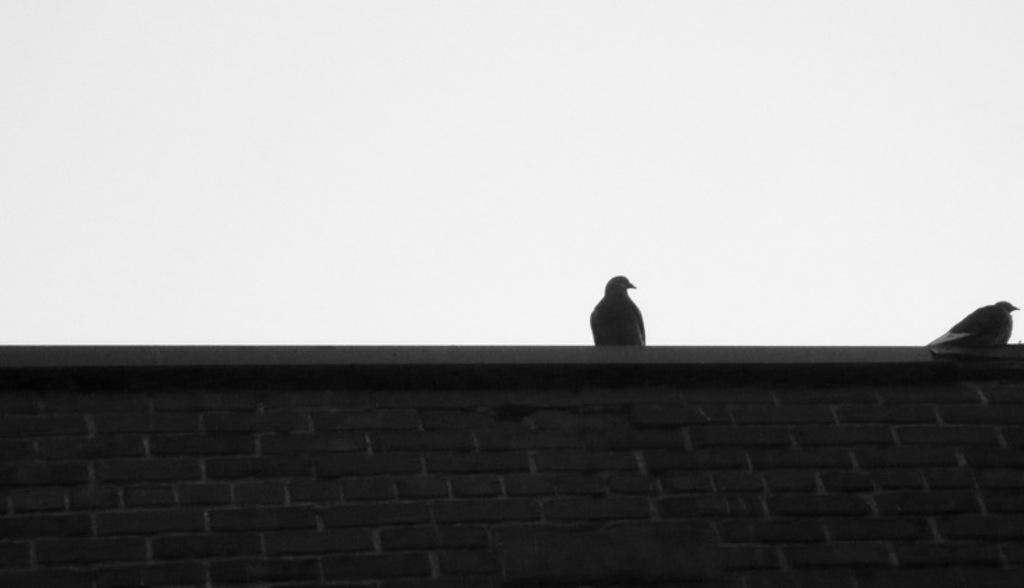How many birds can be seen in the image? There are two birds in the image. Where are the birds located? The birds are on a wall. What is the wall made of? The wall is made up of bricks. What can be seen in the background of the image? There is sky visible in the background of the image. What type of hair can be seen on the birds in the image? There is no hair present on the birds in the image, as birds do not have hair. 